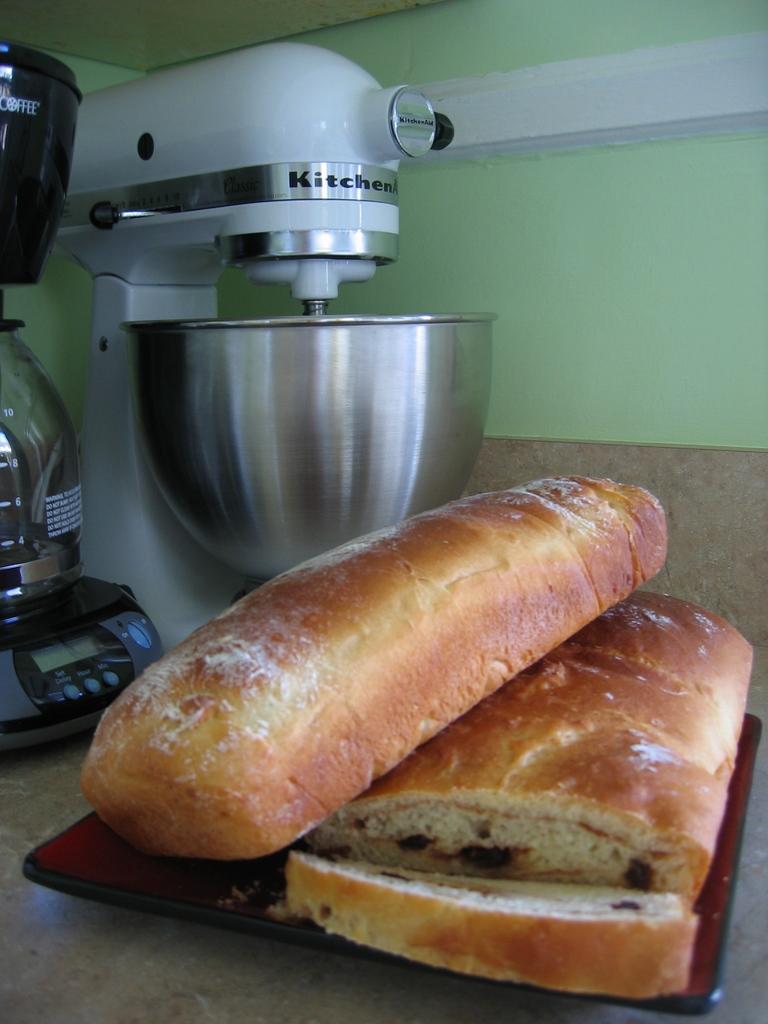What brand is the mixer?
Your answer should be compact. Kitchenaid. This  is  breed?
Provide a short and direct response. Yes. 